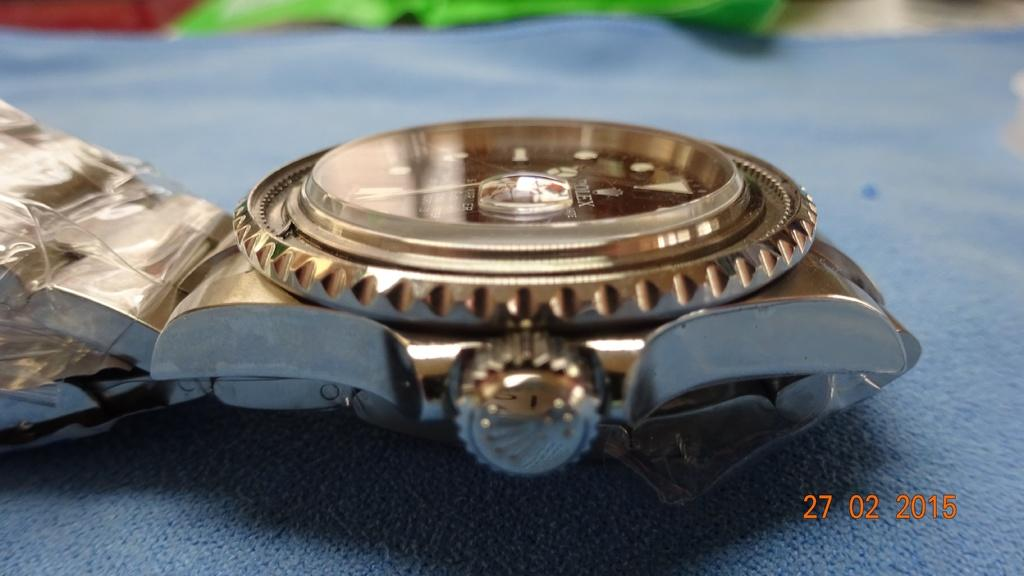<image>
Create a compact narrative representing the image presented. A grey metal Rolex brand watch rests on a blue field. 